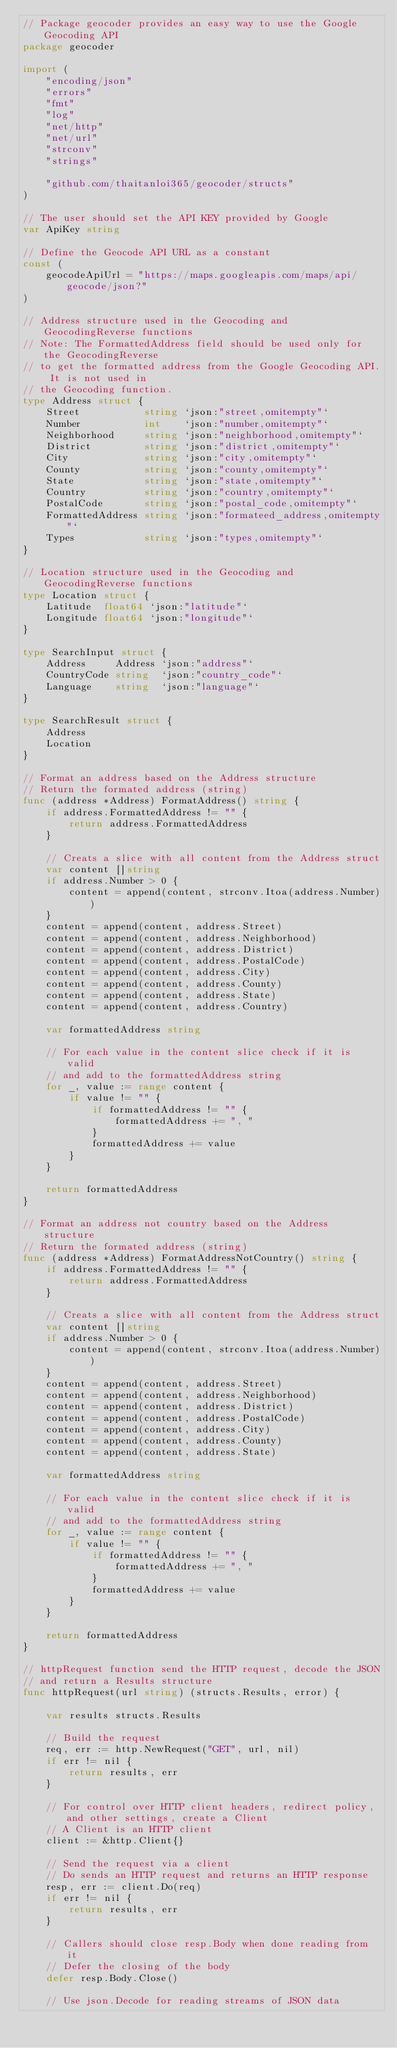Convert code to text. <code><loc_0><loc_0><loc_500><loc_500><_Go_>// Package geocoder provides an easy way to use the Google Geocoding API
package geocoder

import (
	"encoding/json"
	"errors"
	"fmt"
	"log"
	"net/http"
	"net/url"
	"strconv"
	"strings"

	"github.com/thaitanloi365/geocoder/structs"
)

// The user should set the API KEY provided by Google
var ApiKey string

// Define the Geocode API URL as a constant
const (
	geocodeApiUrl = "https://maps.googleapis.com/maps/api/geocode/json?"
)

// Address structure used in the Geocoding and GeocodingReverse functions
// Note: The FormattedAddress field should be used only for the GeocodingReverse
// to get the formatted address from the Google Geocoding API. It is not used in
// the Geocoding function.
type Address struct {
	Street           string `json:"street,omitempty"`
	Number           int    `json:"number,omitempty"`
	Neighborhood     string `json:"neighborhood,omitempty"`
	District         string `json:"district,omitempty"`
	City             string `json:"city,omitempty"`
	County           string `json:"county,omitempty"`
	State            string `json:"state,omitempty"`
	Country          string `json:"country,omitempty"`
	PostalCode       string `json:"postal_code,omitempty"`
	FormattedAddress string `json:"formateed_address,omitempty"`
	Types            string `json:"types,omitempty"`
}

// Location structure used in the Geocoding and GeocodingReverse functions
type Location struct {
	Latitude  float64 `json:"latitude"`
	Longitude float64 `json:"longitude"`
}

type SearchInput struct {
	Address     Address `json:"address"`
	CountryCode string  `json:"country_code"`
	Language    string  `json:"language"`
}

type SearchResult struct {
	Address
	Location
}

// Format an address based on the Address structure
// Return the formated address (string)
func (address *Address) FormatAddress() string {
	if address.FormattedAddress != "" {
		return address.FormattedAddress
	}

	// Creats a slice with all content from the Address struct
	var content []string
	if address.Number > 0 {
		content = append(content, strconv.Itoa(address.Number))
	}
	content = append(content, address.Street)
	content = append(content, address.Neighborhood)
	content = append(content, address.District)
	content = append(content, address.PostalCode)
	content = append(content, address.City)
	content = append(content, address.County)
	content = append(content, address.State)
	content = append(content, address.Country)

	var formattedAddress string

	// For each value in the content slice check if it is valid
	// and add to the formattedAddress string
	for _, value := range content {
		if value != "" {
			if formattedAddress != "" {
				formattedAddress += ", "
			}
			formattedAddress += value
		}
	}

	return formattedAddress
}

// Format an address not country based on the Address structure
// Return the formated address (string)
func (address *Address) FormatAddressNotCountry() string {
	if address.FormattedAddress != "" {
		return address.FormattedAddress
	}

	// Creats a slice with all content from the Address struct
	var content []string
	if address.Number > 0 {
		content = append(content, strconv.Itoa(address.Number))
	}
	content = append(content, address.Street)
	content = append(content, address.Neighborhood)
	content = append(content, address.District)
	content = append(content, address.PostalCode)
	content = append(content, address.City)
	content = append(content, address.County)
	content = append(content, address.State)

	var formattedAddress string

	// For each value in the content slice check if it is valid
	// and add to the formattedAddress string
	for _, value := range content {
		if value != "" {
			if formattedAddress != "" {
				formattedAddress += ", "
			}
			formattedAddress += value
		}
	}

	return formattedAddress
}

// httpRequest function send the HTTP request, decode the JSON
// and return a Results structure
func httpRequest(url string) (structs.Results, error) {

	var results structs.Results

	// Build the request
	req, err := http.NewRequest("GET", url, nil)
	if err != nil {
		return results, err
	}

	// For control over HTTP client headers, redirect policy, and other settings, create a Client
	// A Client is an HTTP client
	client := &http.Client{}

	// Send the request via a client
	// Do sends an HTTP request and returns an HTTP response
	resp, err := client.Do(req)
	if err != nil {
		return results, err
	}

	// Callers should close resp.Body when done reading from it
	// Defer the closing of the body
	defer resp.Body.Close()

	// Use json.Decode for reading streams of JSON data</code> 